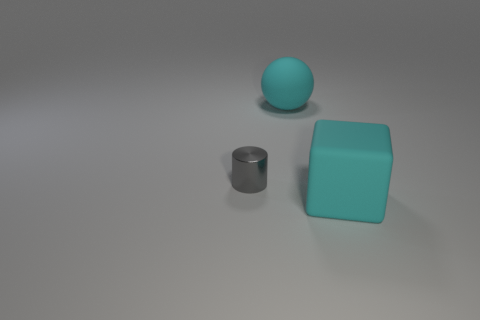Add 2 big cyan matte objects. How many objects exist? 5 Subtract all spheres. How many objects are left? 2 Add 1 rubber cylinders. How many rubber cylinders exist? 1 Subtract 0 brown blocks. How many objects are left? 3 Subtract all large red balls. Subtract all cyan rubber balls. How many objects are left? 2 Add 1 tiny objects. How many tiny objects are left? 2 